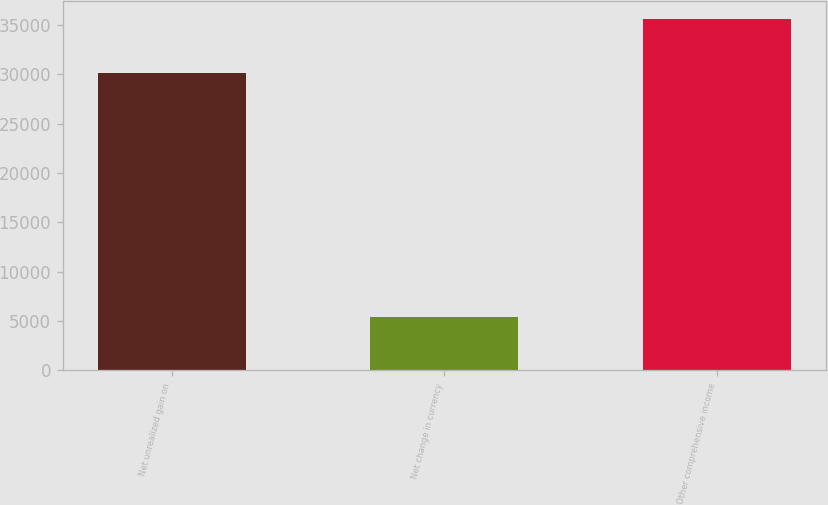Convert chart to OTSL. <chart><loc_0><loc_0><loc_500><loc_500><bar_chart><fcel>Net unrealized gain on<fcel>Net change in currency<fcel>Other comprehensive income<nl><fcel>30147<fcel>5459<fcel>35606<nl></chart> 